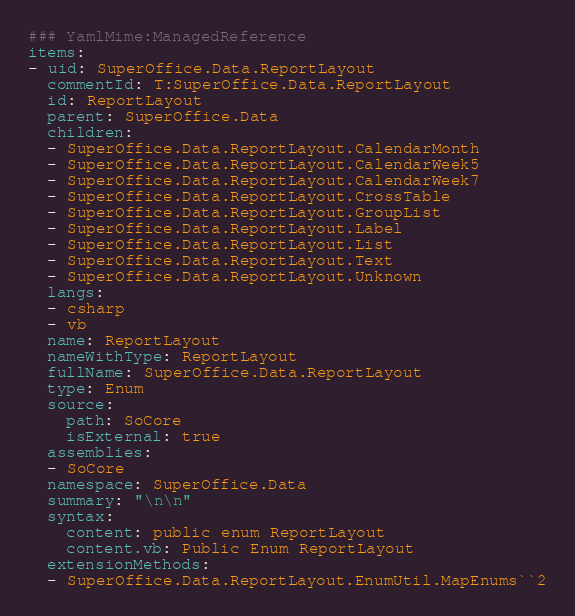Convert code to text. <code><loc_0><loc_0><loc_500><loc_500><_YAML_>### YamlMime:ManagedReference
items:
- uid: SuperOffice.Data.ReportLayout
  commentId: T:SuperOffice.Data.ReportLayout
  id: ReportLayout
  parent: SuperOffice.Data
  children:
  - SuperOffice.Data.ReportLayout.CalendarMonth
  - SuperOffice.Data.ReportLayout.CalendarWeek5
  - SuperOffice.Data.ReportLayout.CalendarWeek7
  - SuperOffice.Data.ReportLayout.CrossTable
  - SuperOffice.Data.ReportLayout.GroupList
  - SuperOffice.Data.ReportLayout.Label
  - SuperOffice.Data.ReportLayout.List
  - SuperOffice.Data.ReportLayout.Text
  - SuperOffice.Data.ReportLayout.Unknown
  langs:
  - csharp
  - vb
  name: ReportLayout
  nameWithType: ReportLayout
  fullName: SuperOffice.Data.ReportLayout
  type: Enum
  source:
    path: SoCore
    isExternal: true
  assemblies:
  - SoCore
  namespace: SuperOffice.Data
  summary: "\n\n"
  syntax:
    content: public enum ReportLayout
    content.vb: Public Enum ReportLayout
  extensionMethods:
  - SuperOffice.Data.ReportLayout.EnumUtil.MapEnums``2</code> 